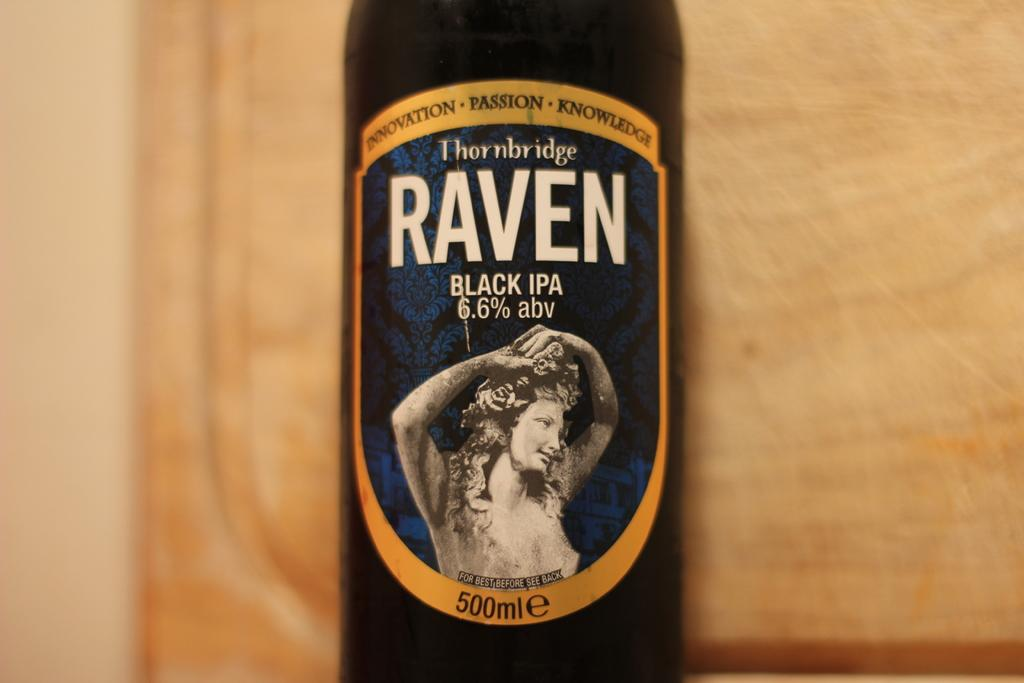Provide a one-sentence caption for the provided image. Raven Black IPA contains 6.6% abv and is available in a 500mlE bottle. 